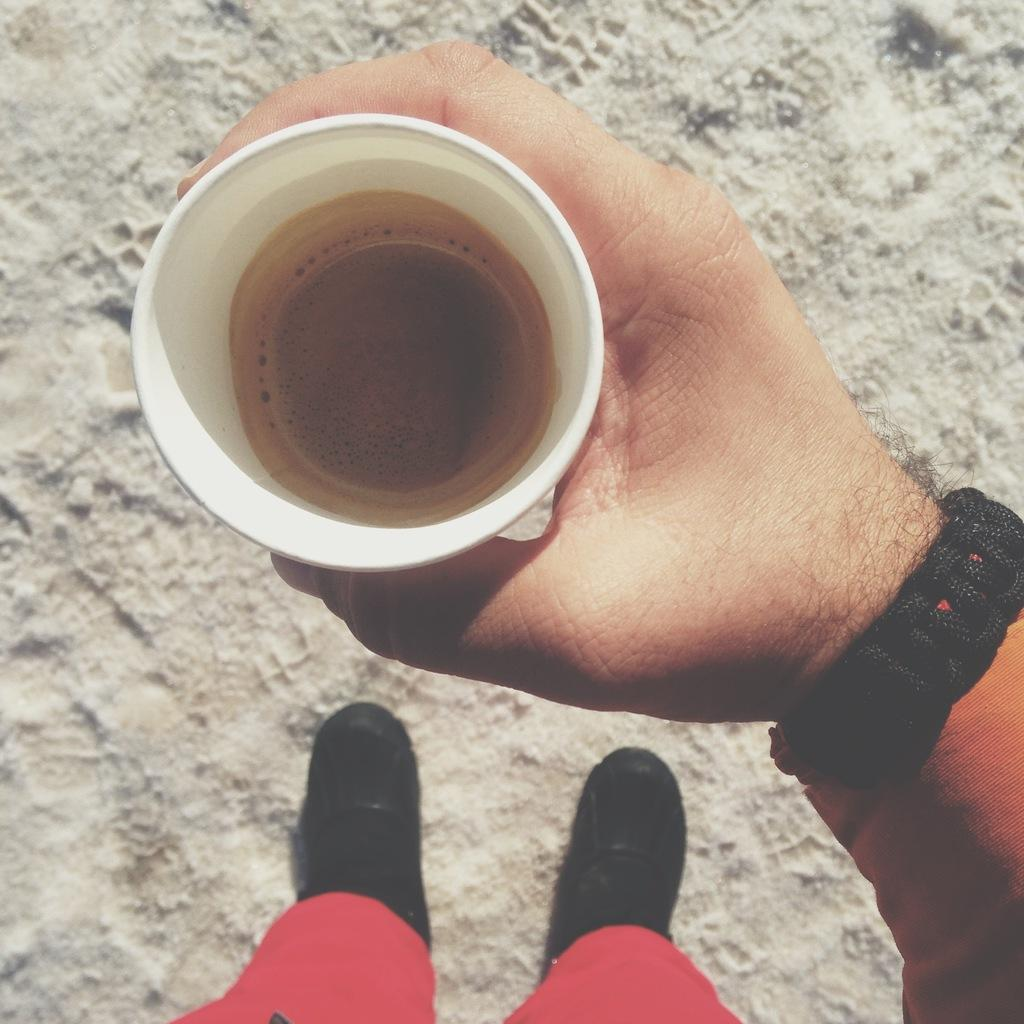What is the person in the image doing? The person is standing in the image and holding a cup. What is in the cup that the person is holding? There is a drink in the cup. Can you describe any accessories the person is wearing? The person is wearing a watch. What can be seen in the background of the image? There is sand visible in the background of the image. How many sponges are being used by the person in the image? There are no sponges present in the image. What type of cars can be seen in the background of the image? There are no cars visible in the image; only sand can be seen in the background. 